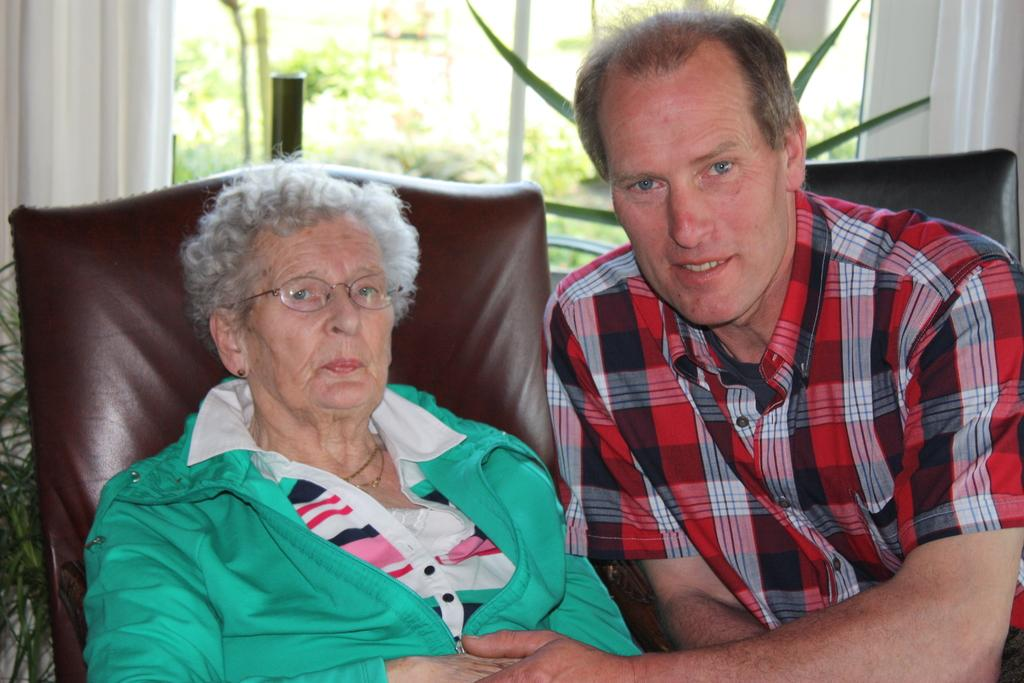Who is in the image? There is an old lady and a person sitting on a couch in the image. What are they doing? The old lady and the person are sitting on a couch together. What can be seen in the background of the image? There are plants visible in the image, and there is a window through which trees and plants can be seen. What type of harbor can be seen in the image? There is no harbor present in the image; it features an old lady and a person sitting on a couch with plants and a window in the background. How many steps are visible in the image? There is no mention of steps in the image; it only shows an old lady, a person sitting on a couch, plants, and a window. 